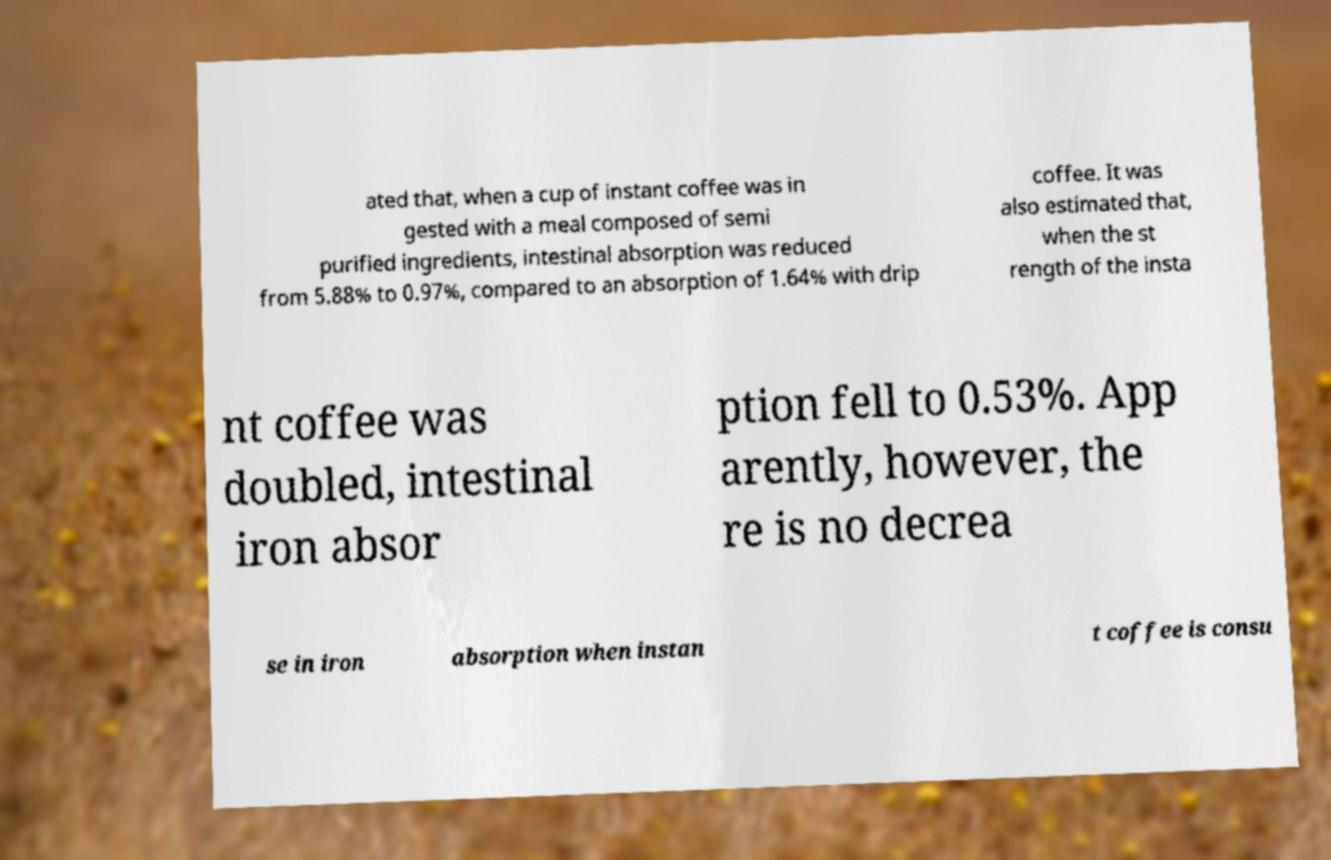Please identify and transcribe the text found in this image. ated that, when a cup of instant coffee was in gested with a meal composed of semi purified ingredients, intestinal absorption was reduced from 5.88% to 0.97%, compared to an absorption of 1.64% with drip coffee. It was also estimated that, when the st rength of the insta nt coffee was doubled, intestinal iron absor ption fell to 0.53%. App arently, however, the re is no decrea se in iron absorption when instan t coffee is consu 